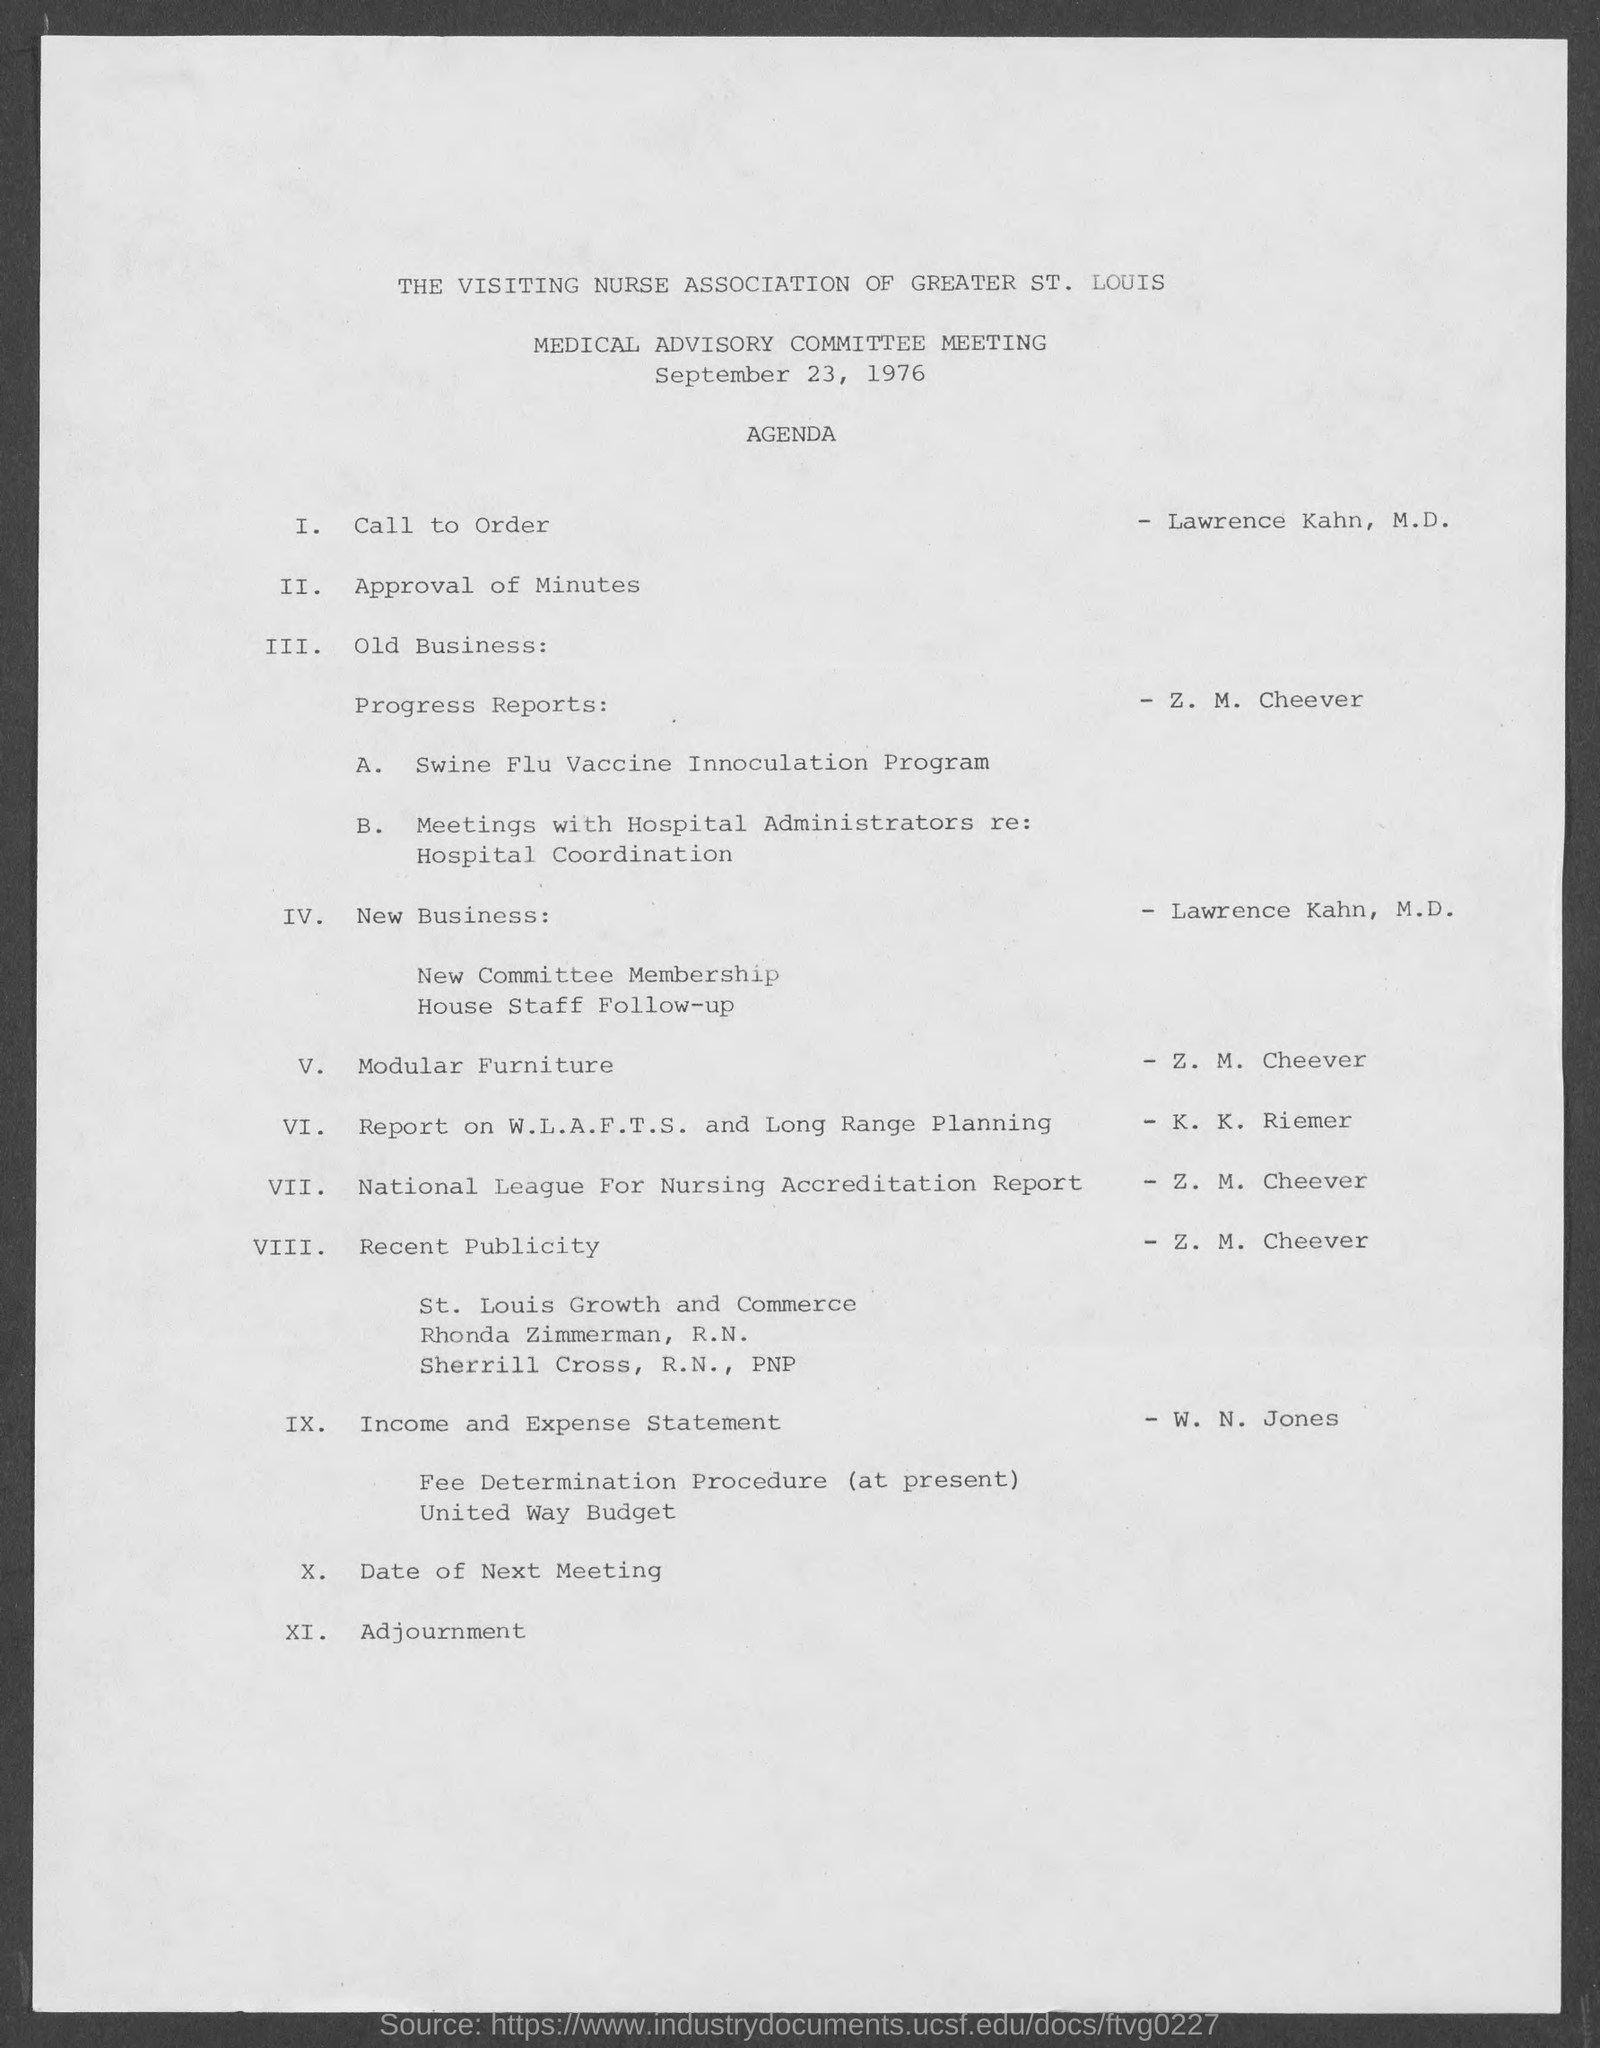When was the Medical Advisory Committee Meeting Scheduled?
Provide a succinct answer. September 23, 1976. Who will present the Income and Expense Statement as per the agenda?
Ensure brevity in your answer.  W. n. jones. 